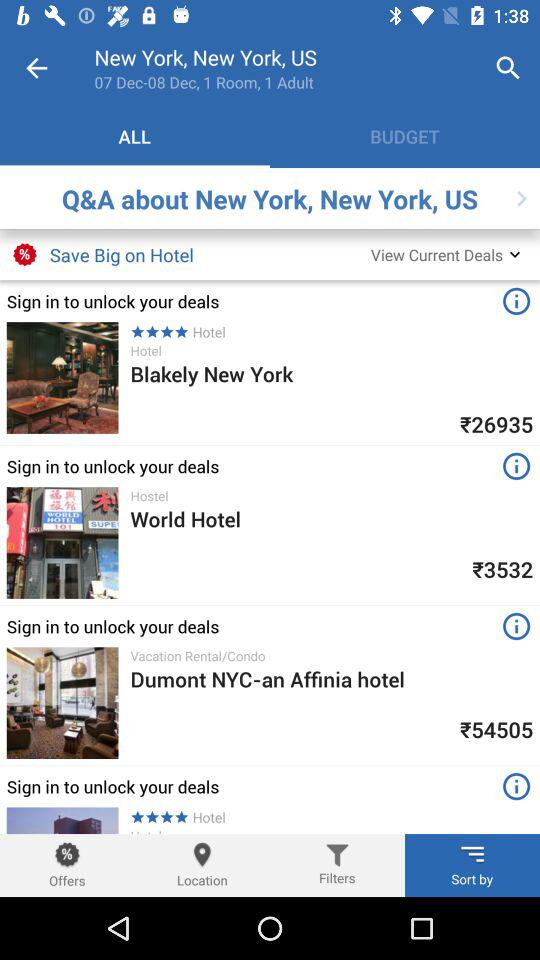How many adults have been selected? The selected adult is 1. 